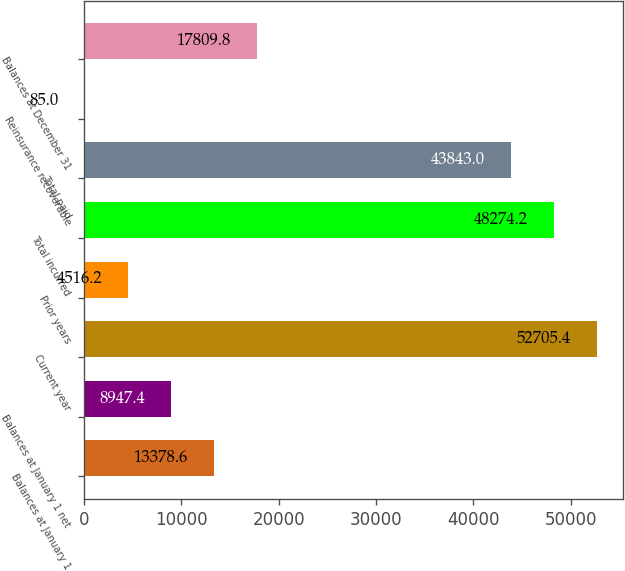<chart> <loc_0><loc_0><loc_500><loc_500><bar_chart><fcel>Balances at January 1<fcel>Balances at January 1 net<fcel>Current year<fcel>Prior years<fcel>Total incurred<fcel>Total paid<fcel>Reinsurance recoverable<fcel>Balances at December 31<nl><fcel>13378.6<fcel>8947.4<fcel>52705.4<fcel>4516.2<fcel>48274.2<fcel>43843<fcel>85<fcel>17809.8<nl></chart> 